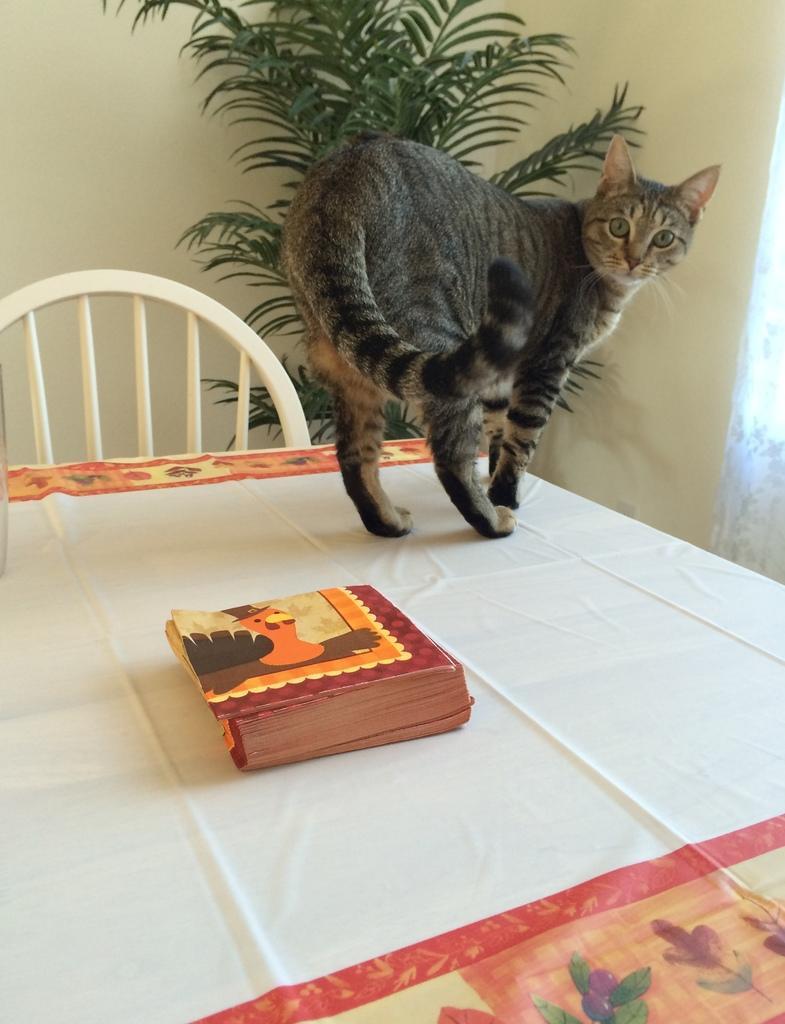Can you describe this image briefly? In this picture there is a cat on the table at the center of the image and there is a plant behind the cat, there is a book on the table at the center of the image, and there is a chair at the left side of the image and a window at the right side of the image, there is white color covering on the table. 